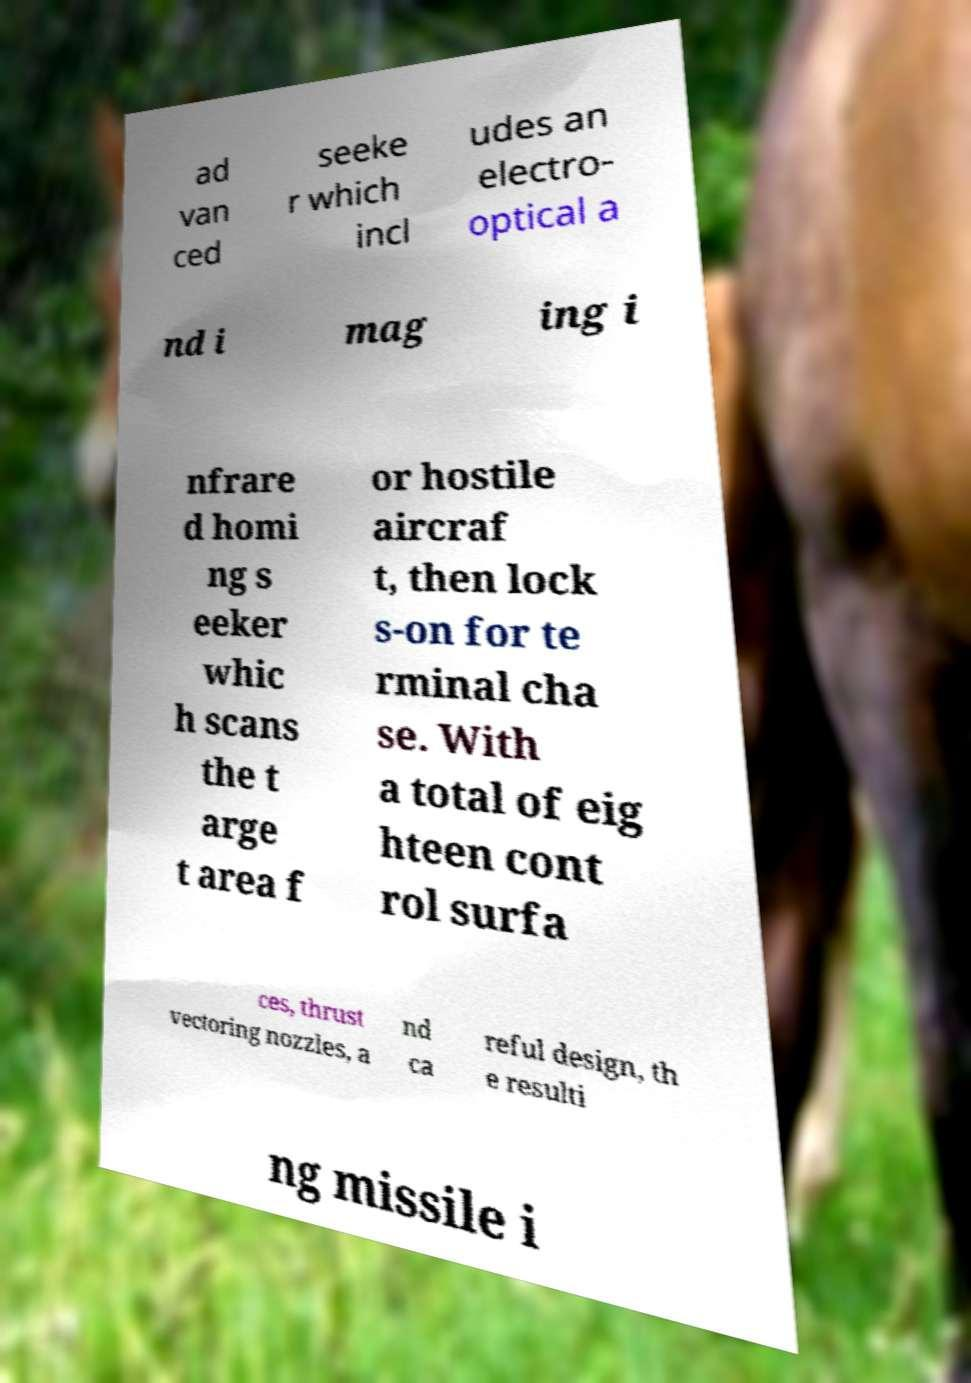Please read and relay the text visible in this image. What does it say? ad van ced seeke r which incl udes an electro- optical a nd i mag ing i nfrare d homi ng s eeker whic h scans the t arge t area f or hostile aircraf t, then lock s-on for te rminal cha se. With a total of eig hteen cont rol surfa ces, thrust vectoring nozzles, a nd ca reful design, th e resulti ng missile i 